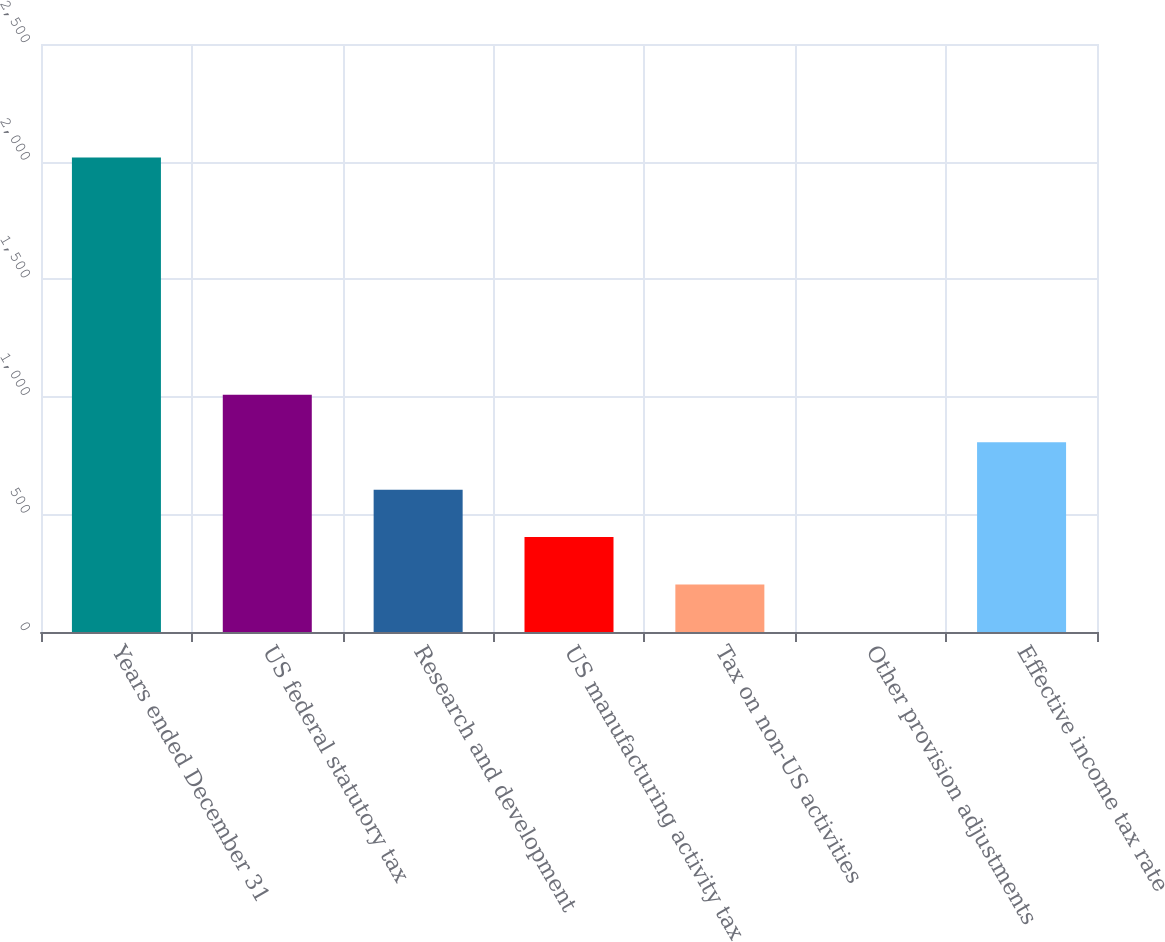<chart> <loc_0><loc_0><loc_500><loc_500><bar_chart><fcel>Years ended December 31<fcel>US federal statutory tax<fcel>Research and development<fcel>US manufacturing activity tax<fcel>Tax on non-US activities<fcel>Other provision adjustments<fcel>Effective income tax rate<nl><fcel>2017<fcel>1008.6<fcel>605.24<fcel>403.56<fcel>201.88<fcel>0.2<fcel>806.92<nl></chart> 